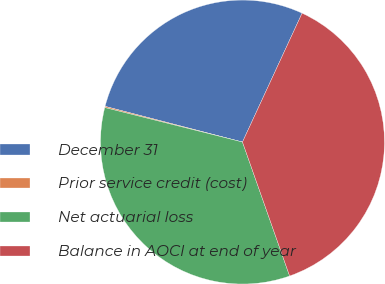<chart> <loc_0><loc_0><loc_500><loc_500><pie_chart><fcel>December 31<fcel>Prior service credit (cost)<fcel>Net actuarial loss<fcel>Balance in AOCI at end of year<nl><fcel>27.85%<fcel>0.14%<fcel>34.29%<fcel>37.72%<nl></chart> 